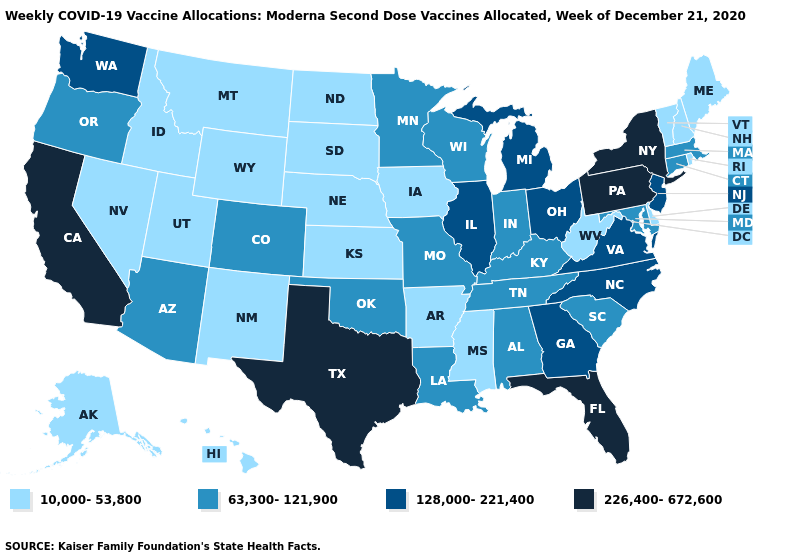Name the states that have a value in the range 63,300-121,900?
Short answer required. Alabama, Arizona, Colorado, Connecticut, Indiana, Kentucky, Louisiana, Maryland, Massachusetts, Minnesota, Missouri, Oklahoma, Oregon, South Carolina, Tennessee, Wisconsin. Does Utah have the lowest value in the USA?
Keep it brief. Yes. Among the states that border Indiana , does Illinois have the lowest value?
Concise answer only. No. What is the lowest value in the West?
Give a very brief answer. 10,000-53,800. What is the highest value in the South ?
Quick response, please. 226,400-672,600. Name the states that have a value in the range 10,000-53,800?
Quick response, please. Alaska, Arkansas, Delaware, Hawaii, Idaho, Iowa, Kansas, Maine, Mississippi, Montana, Nebraska, Nevada, New Hampshire, New Mexico, North Dakota, Rhode Island, South Dakota, Utah, Vermont, West Virginia, Wyoming. Name the states that have a value in the range 63,300-121,900?
Short answer required. Alabama, Arizona, Colorado, Connecticut, Indiana, Kentucky, Louisiana, Maryland, Massachusetts, Minnesota, Missouri, Oklahoma, Oregon, South Carolina, Tennessee, Wisconsin. Name the states that have a value in the range 63,300-121,900?
Answer briefly. Alabama, Arizona, Colorado, Connecticut, Indiana, Kentucky, Louisiana, Maryland, Massachusetts, Minnesota, Missouri, Oklahoma, Oregon, South Carolina, Tennessee, Wisconsin. Name the states that have a value in the range 128,000-221,400?
Give a very brief answer. Georgia, Illinois, Michigan, New Jersey, North Carolina, Ohio, Virginia, Washington. Name the states that have a value in the range 63,300-121,900?
Concise answer only. Alabama, Arizona, Colorado, Connecticut, Indiana, Kentucky, Louisiana, Maryland, Massachusetts, Minnesota, Missouri, Oklahoma, Oregon, South Carolina, Tennessee, Wisconsin. Does the first symbol in the legend represent the smallest category?
Quick response, please. Yes. Name the states that have a value in the range 63,300-121,900?
Write a very short answer. Alabama, Arizona, Colorado, Connecticut, Indiana, Kentucky, Louisiana, Maryland, Massachusetts, Minnesota, Missouri, Oklahoma, Oregon, South Carolina, Tennessee, Wisconsin. Name the states that have a value in the range 226,400-672,600?
Give a very brief answer. California, Florida, New York, Pennsylvania, Texas. What is the value of New Jersey?
Write a very short answer. 128,000-221,400. Does Florida have the highest value in the USA?
Short answer required. Yes. 